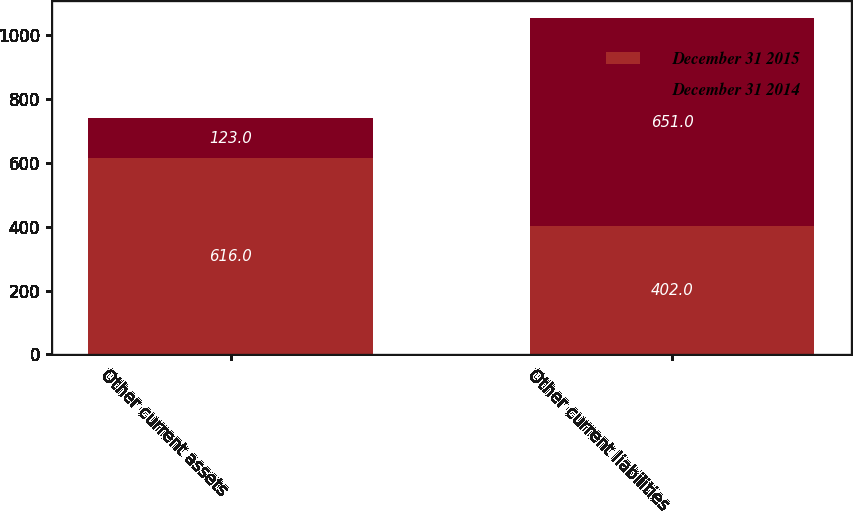Convert chart. <chart><loc_0><loc_0><loc_500><loc_500><stacked_bar_chart><ecel><fcel>Other current assets<fcel>Other current liabilities<nl><fcel>December 31 2015<fcel>616<fcel>402<nl><fcel>December 31 2014<fcel>123<fcel>651<nl></chart> 